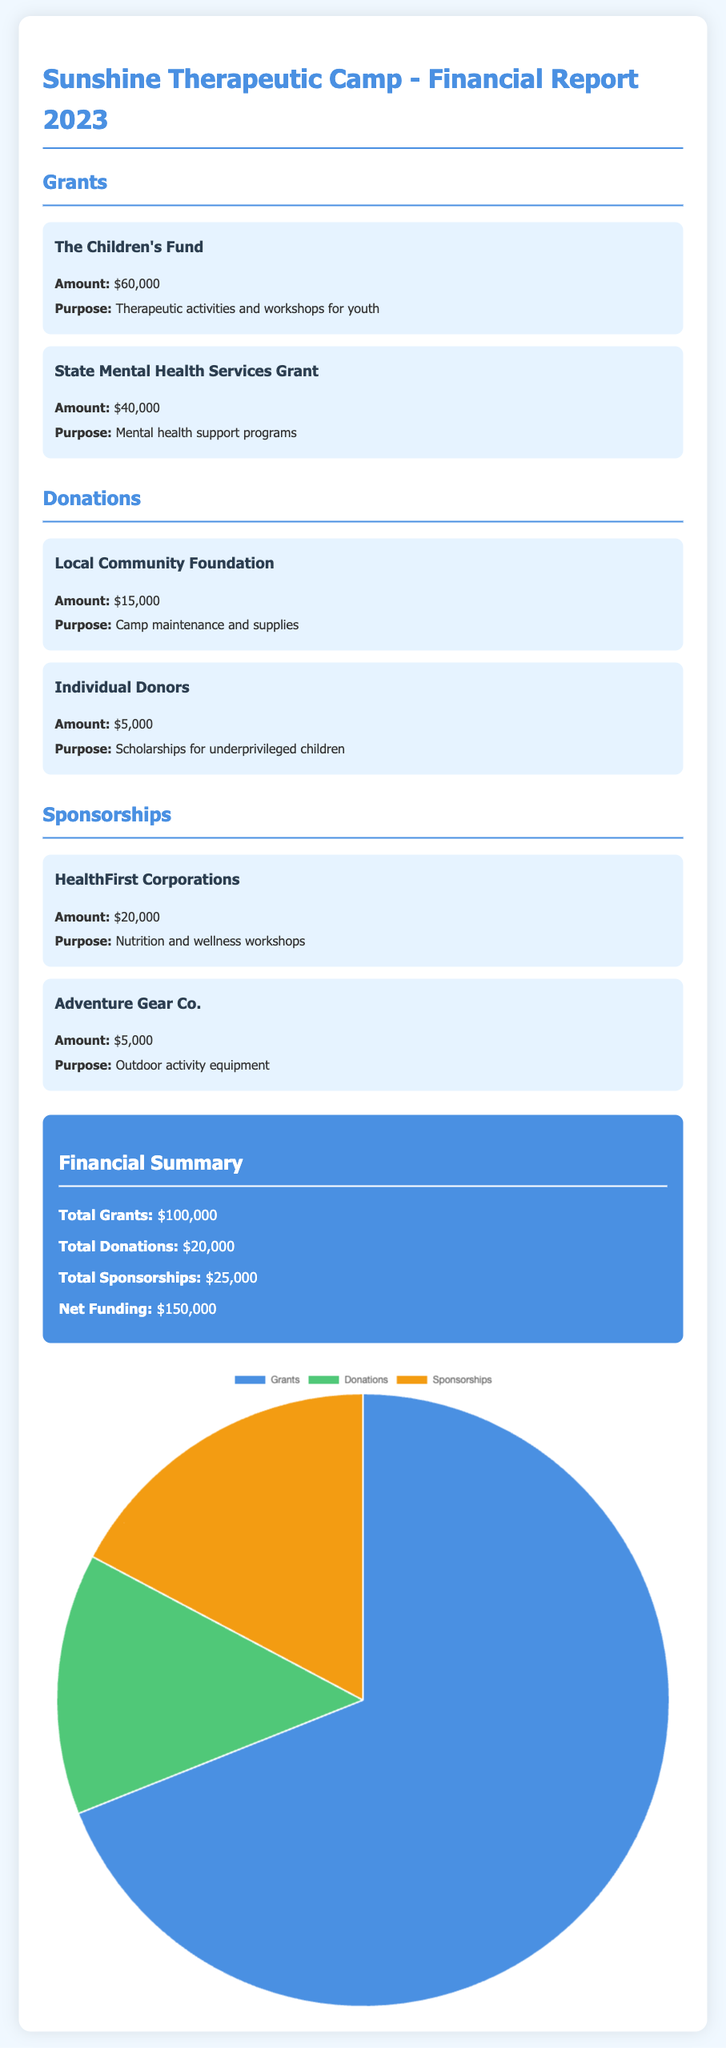What is the total amount received from grants? The total amount received from grants is detailed in the financial summary and sums up the individual grants listed.
Answer: $100,000 What is the purpose of the funding from The Children's Fund? The purpose mentioned for The Children's Fund is for therapeutic activities and workshops for youth.
Answer: Therapeutic activities and workshops for youth Which organization contributed for camp maintenance and supplies? The document specifies that the Local Community Foundation provided the funding for camp maintenance and supplies.
Answer: Local Community Foundation How much did HealthFirst Corporations contribute? The contribution from HealthFirst Corporations is shown in the sponsorship section of the document.
Answer: $20,000 What is the purpose of the funding provided by Adventure Gear Co.? The purpose outlined for Adventure Gear Co. is related to outdoor activity equipment.
Answer: Outdoor activity equipment What is the total funding net amount? The net funding amount is calculated in the financial summary section of the report, accounting for all funding sources.
Answer: $150,000 What percentage of total funding comes from donations? The donations amount is divided by the total funding to find the percentage; it is part of the financial summary.
Answer: 13.33% What is the total amount from individual donors? The financial report specifies the contribution amount from individual donors under the donations section.
Answer: $5,000 What is the title of the document? The title of the document is presented at the beginning of the report.
Answer: Sunshine Therapeutic Camp - Financial Report 2023 